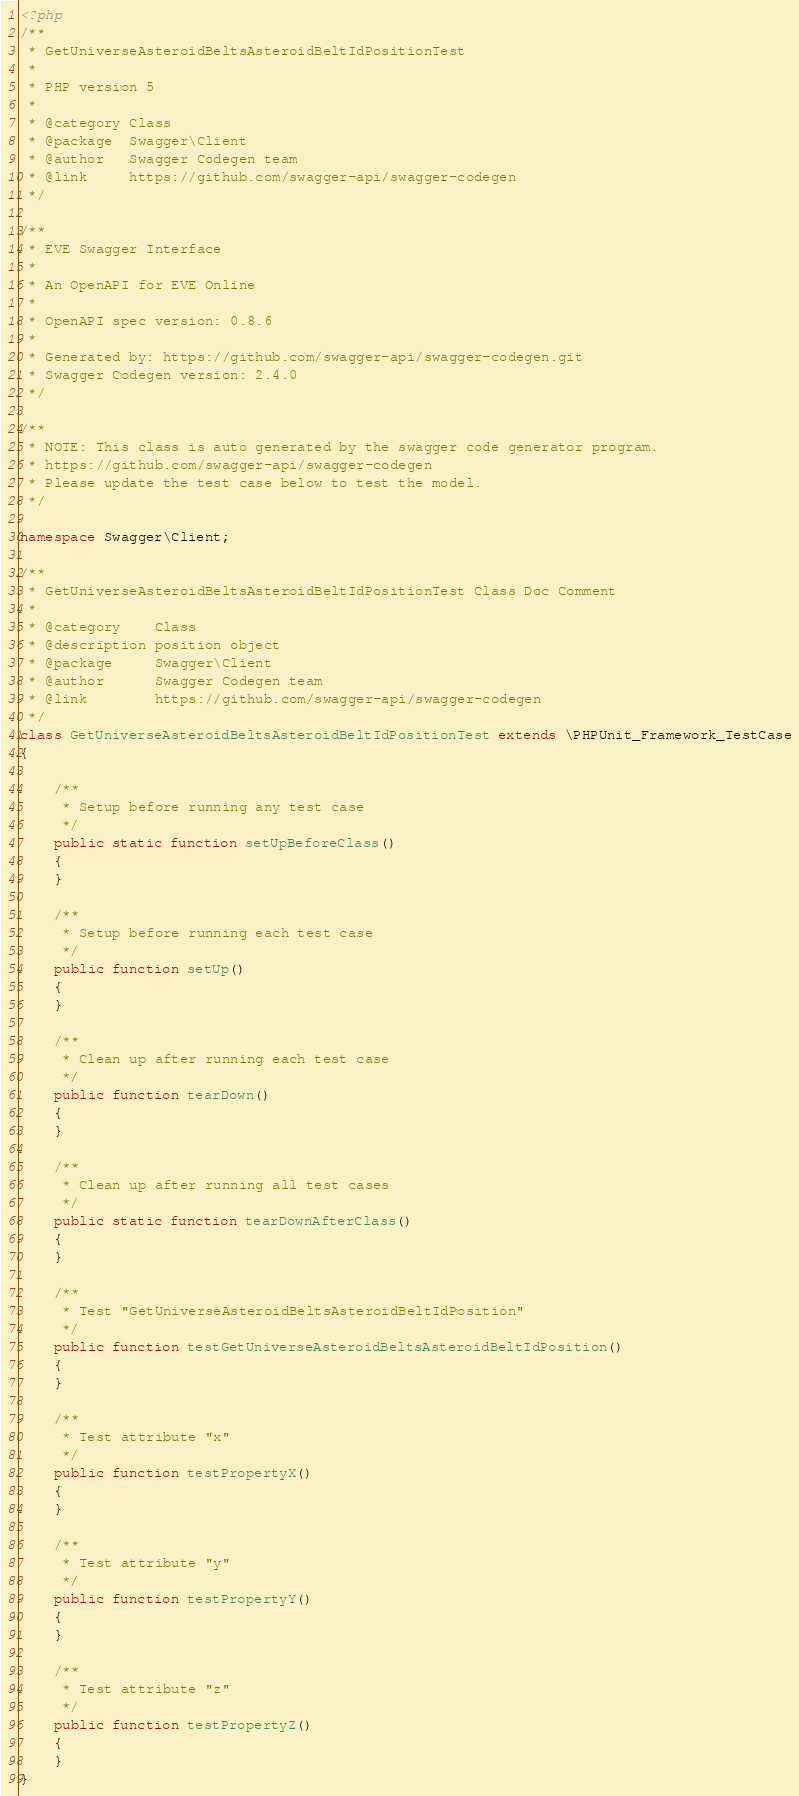Convert code to text. <code><loc_0><loc_0><loc_500><loc_500><_PHP_><?php
/**
 * GetUniverseAsteroidBeltsAsteroidBeltIdPositionTest
 *
 * PHP version 5
 *
 * @category Class
 * @package  Swagger\Client
 * @author   Swagger Codegen team
 * @link     https://github.com/swagger-api/swagger-codegen
 */

/**
 * EVE Swagger Interface
 *
 * An OpenAPI for EVE Online
 *
 * OpenAPI spec version: 0.8.6
 * 
 * Generated by: https://github.com/swagger-api/swagger-codegen.git
 * Swagger Codegen version: 2.4.0
 */

/**
 * NOTE: This class is auto generated by the swagger code generator program.
 * https://github.com/swagger-api/swagger-codegen
 * Please update the test case below to test the model.
 */

namespace Swagger\Client;

/**
 * GetUniverseAsteroidBeltsAsteroidBeltIdPositionTest Class Doc Comment
 *
 * @category    Class
 * @description position object
 * @package     Swagger\Client
 * @author      Swagger Codegen team
 * @link        https://github.com/swagger-api/swagger-codegen
 */
class GetUniverseAsteroidBeltsAsteroidBeltIdPositionTest extends \PHPUnit_Framework_TestCase
{

    /**
     * Setup before running any test case
     */
    public static function setUpBeforeClass()
    {
    }

    /**
     * Setup before running each test case
     */
    public function setUp()
    {
    }

    /**
     * Clean up after running each test case
     */
    public function tearDown()
    {
    }

    /**
     * Clean up after running all test cases
     */
    public static function tearDownAfterClass()
    {
    }

    /**
     * Test "GetUniverseAsteroidBeltsAsteroidBeltIdPosition"
     */
    public function testGetUniverseAsteroidBeltsAsteroidBeltIdPosition()
    {
    }

    /**
     * Test attribute "x"
     */
    public function testPropertyX()
    {
    }

    /**
     * Test attribute "y"
     */
    public function testPropertyY()
    {
    }

    /**
     * Test attribute "z"
     */
    public function testPropertyZ()
    {
    }
}
</code> 